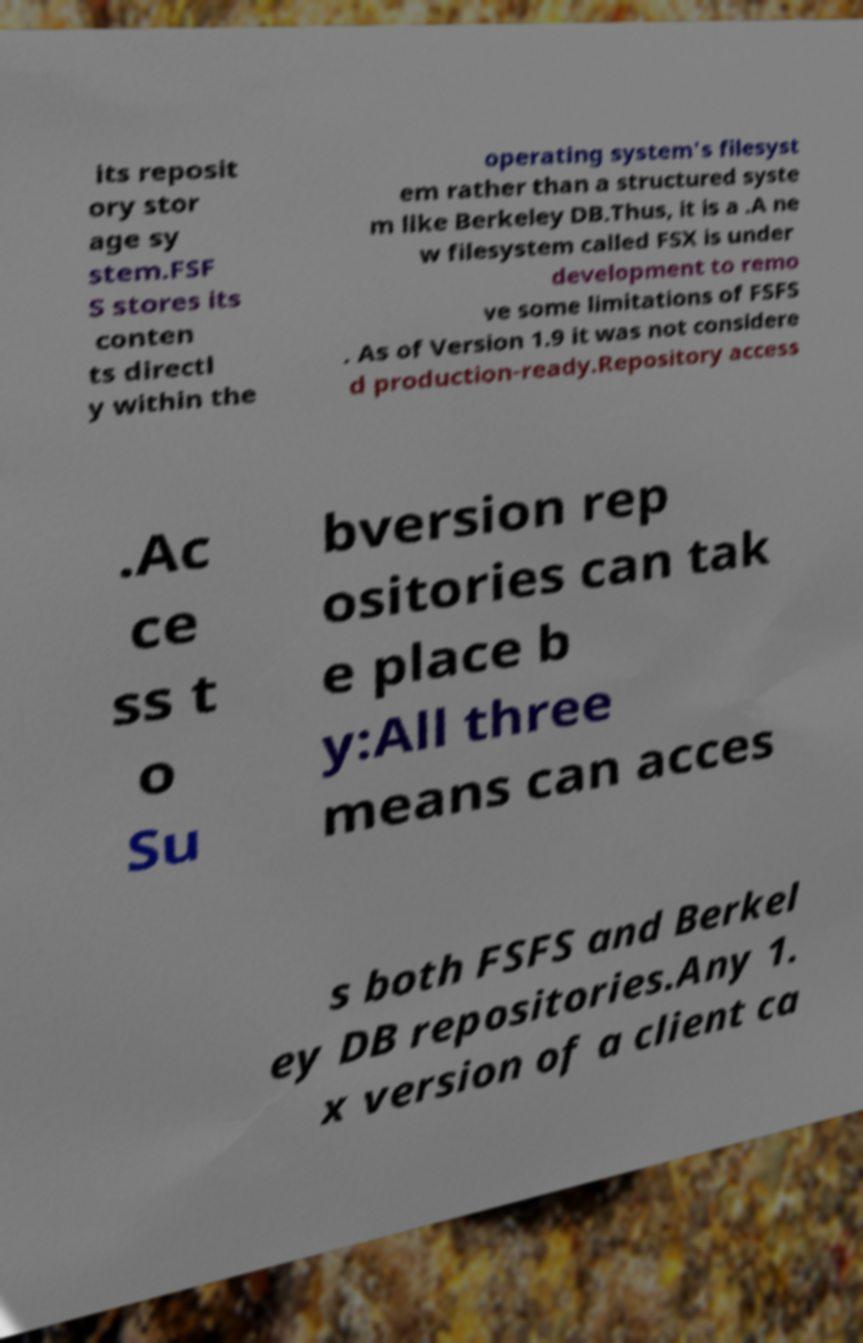Can you read and provide the text displayed in the image?This photo seems to have some interesting text. Can you extract and type it out for me? its reposit ory stor age sy stem.FSF S stores its conten ts directl y within the operating system's filesyst em rather than a structured syste m like Berkeley DB.Thus, it is a .A ne w filesystem called FSX is under development to remo ve some limitations of FSFS . As of Version 1.9 it was not considere d production-ready.Repository access .Ac ce ss t o Su bversion rep ositories can tak e place b y:All three means can acces s both FSFS and Berkel ey DB repositories.Any 1. x version of a client ca 